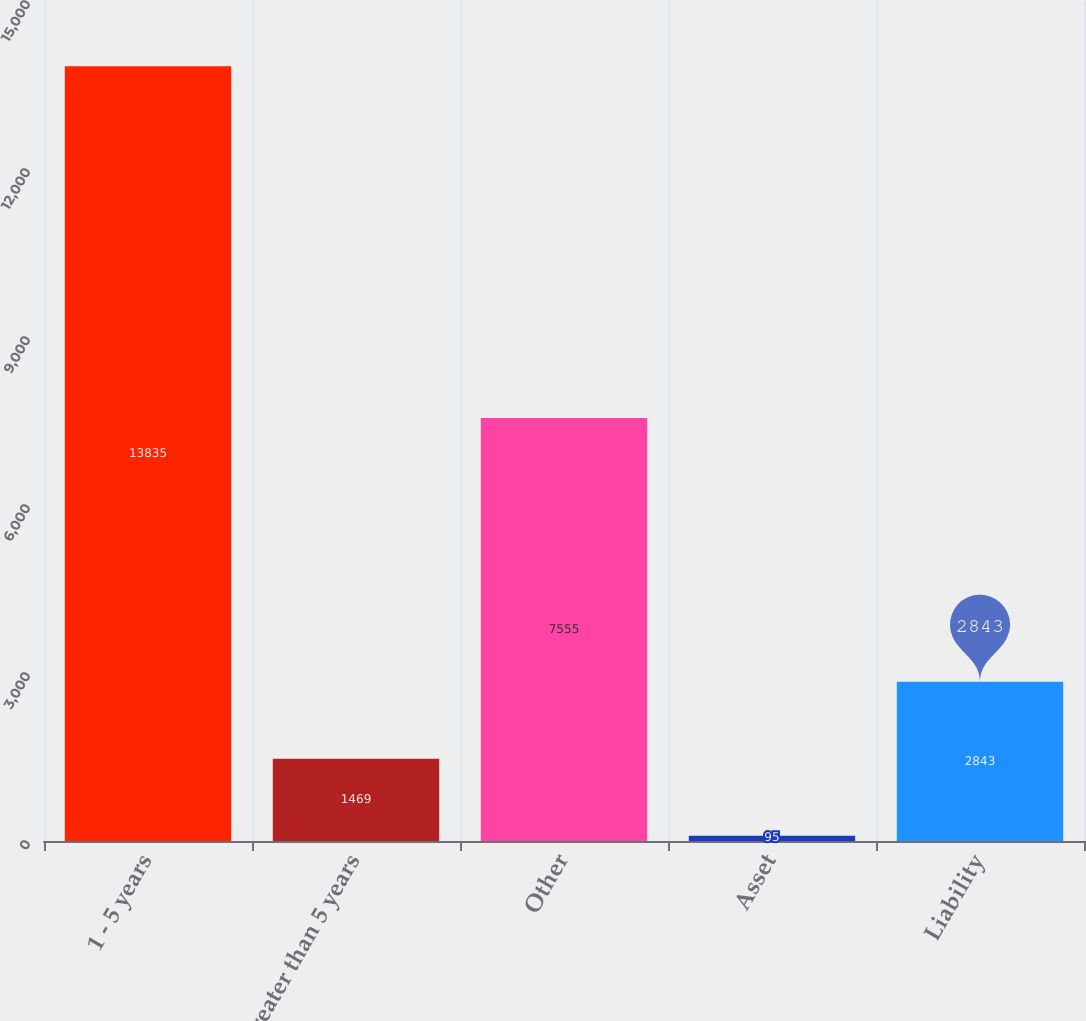<chart> <loc_0><loc_0><loc_500><loc_500><bar_chart><fcel>1 - 5 years<fcel>Greater than 5 years<fcel>Other<fcel>Asset<fcel>Liability<nl><fcel>13835<fcel>1469<fcel>7555<fcel>95<fcel>2843<nl></chart> 